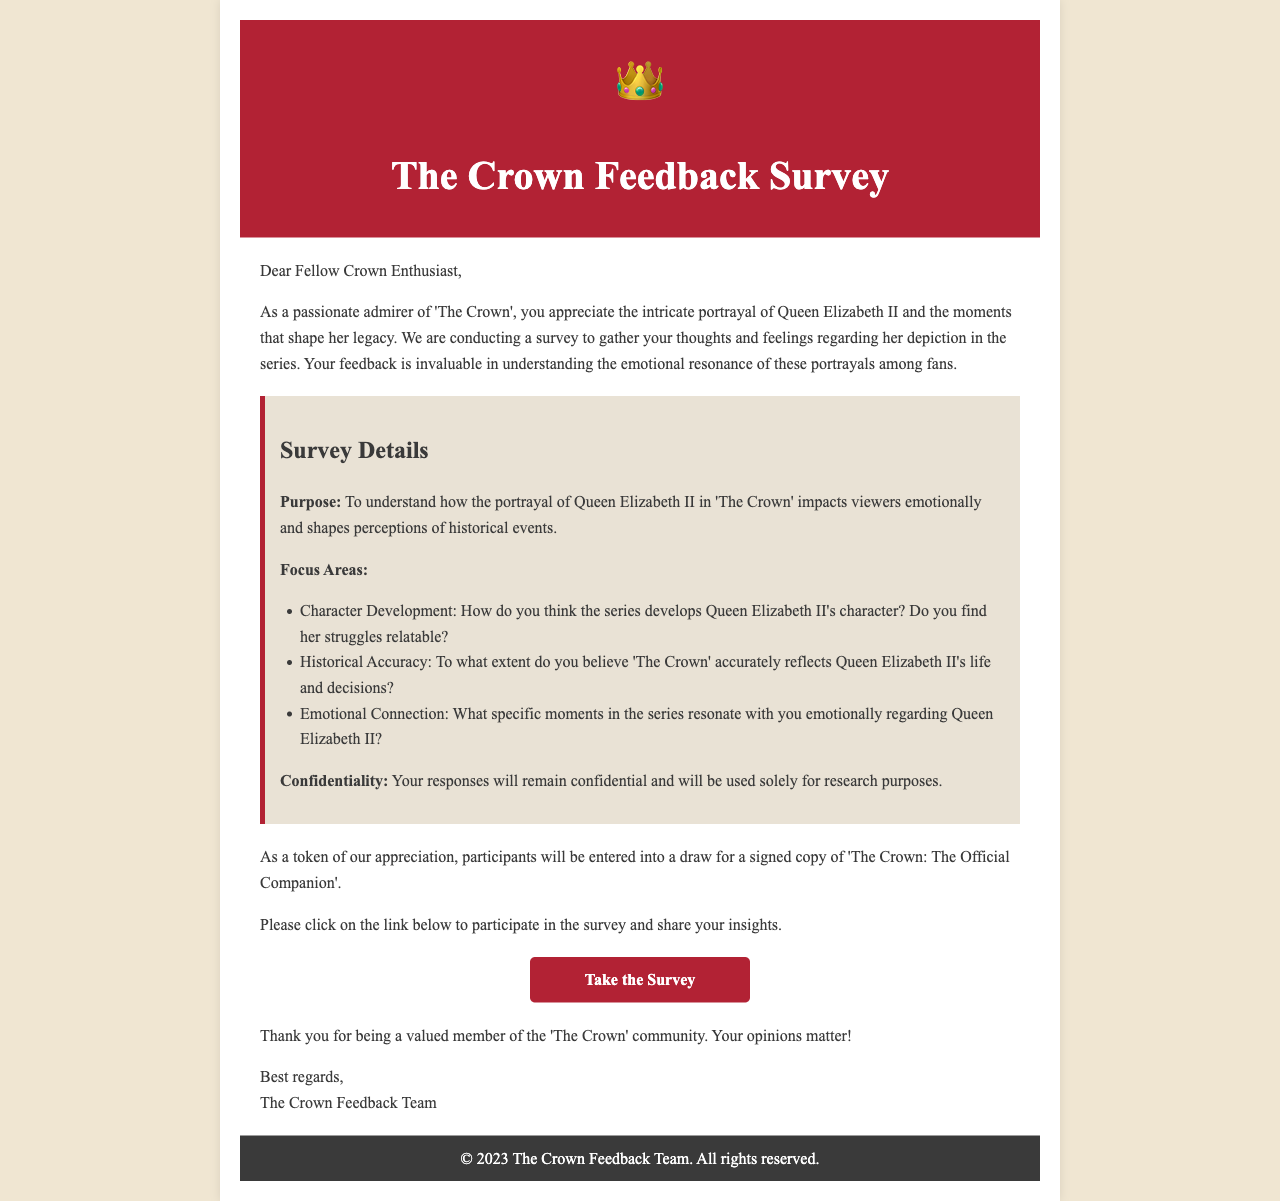what is the title of the survey? The title of the survey is presented prominently at the top of the document.
Answer: The Crown Feedback Survey who is the intended audience for the survey? The document addresses a specific group of people, which indicates the target audience for the survey.
Answer: Fellow Crown Enthusiast what is the purpose of the survey? The purpose is explicitly stated in the survey details section of the document.
Answer: To understand how the portrayal of Queen Elizabeth II impacts viewers emotionally how many focus areas are mentioned in the survey? The number of focus areas can be counted from the document section that lists them.
Answer: Three what will participants enter a draw for? The document mentions a prize for participants, which indicates what they might win.
Answer: A signed copy of 'The Crown: The Official Companion' what year was the feedback survey published? The copyright notice at the bottom of the document indicates the year of publication.
Answer: 2023 what is guaranteed about participant responses? The document assures confidentiality regarding responses, indicating how the data will be handled.
Answer: Confidentiality what emotion does the survey seek to evaluate? The document emphasizes feelings associated with the portrayal of Queen Elizabeth II, indicating the emotional aspect it seeks to evaluate.
Answer: Emotional connection where can participants take the survey? The link provided in the document directs participants to the survey.
Answer: https://www.surveylink.com/thecrownfeedback 